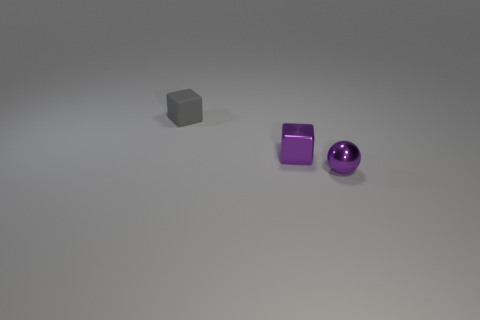Subtract all brown spheres. Subtract all brown cubes. How many spheres are left? 1 Add 2 tiny gray metallic things. How many objects exist? 5 Subtract all spheres. How many objects are left? 2 Add 3 purple balls. How many purple balls are left? 4 Add 1 gray rubber blocks. How many gray rubber blocks exist? 2 Subtract 0 blue cylinders. How many objects are left? 3 Subtract all blocks. Subtract all gray rubber cubes. How many objects are left? 0 